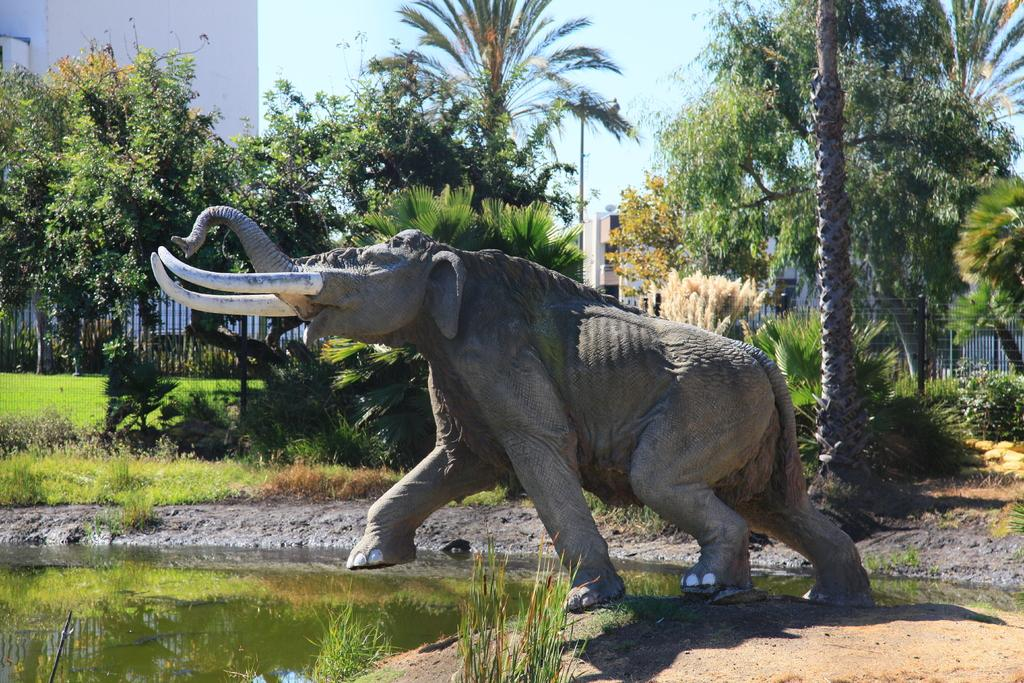What animal can be seen in the image? There is an elephant in the image. What type of vegetation is present in the image? There is grass, a plant, and trees in the image. What type of terrain is visible in the image? There is mud and water in the image. What structures are present in the image? There is a pole, buildings, and a fence in the image. What is the color of the sky in the image? The sky is pale blue in the image. What word is being used to control the thunder in the image? There is no word or thunder present in the image; it features an elephant in a natural environment with various structures and terrain. 